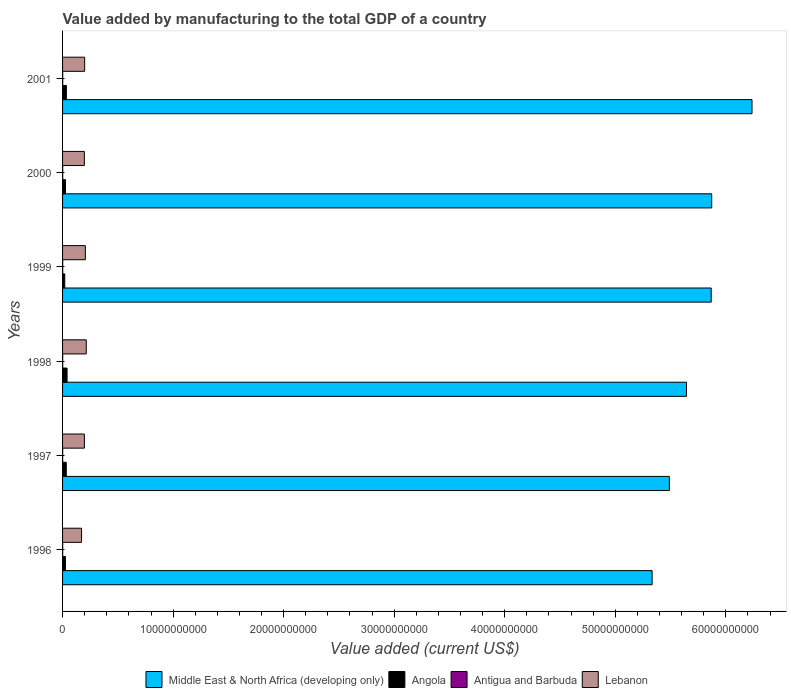How many different coloured bars are there?
Offer a terse response. 4. Are the number of bars per tick equal to the number of legend labels?
Ensure brevity in your answer.  Yes. Are the number of bars on each tick of the Y-axis equal?
Make the answer very short. Yes. How many bars are there on the 5th tick from the top?
Make the answer very short. 4. In how many cases, is the number of bars for a given year not equal to the number of legend labels?
Offer a terse response. 0. What is the value added by manufacturing to the total GDP in Angola in 1997?
Provide a short and direct response. 3.35e+08. Across all years, what is the maximum value added by manufacturing to the total GDP in Antigua and Barbuda?
Give a very brief answer. 1.39e+07. Across all years, what is the minimum value added by manufacturing to the total GDP in Middle East & North Africa (developing only)?
Give a very brief answer. 5.33e+1. In which year was the value added by manufacturing to the total GDP in Middle East & North Africa (developing only) maximum?
Your answer should be compact. 2001. In which year was the value added by manufacturing to the total GDP in Antigua and Barbuda minimum?
Provide a succinct answer. 1996. What is the total value added by manufacturing to the total GDP in Antigua and Barbuda in the graph?
Offer a very short reply. 7.24e+07. What is the difference between the value added by manufacturing to the total GDP in Lebanon in 1998 and that in 2001?
Your answer should be compact. 1.45e+08. What is the difference between the value added by manufacturing to the total GDP in Middle East & North Africa (developing only) in 1996 and the value added by manufacturing to the total GDP in Antigua and Barbuda in 1999?
Keep it short and to the point. 5.33e+1. What is the average value added by manufacturing to the total GDP in Lebanon per year?
Offer a very short reply. 1.98e+09. In the year 1999, what is the difference between the value added by manufacturing to the total GDP in Angola and value added by manufacturing to the total GDP in Middle East & North Africa (developing only)?
Your answer should be compact. -5.85e+1. What is the ratio of the value added by manufacturing to the total GDP in Antigua and Barbuda in 1996 to that in 2000?
Make the answer very short. 0.74. Is the value added by manufacturing to the total GDP in Antigua and Barbuda in 2000 less than that in 2001?
Your answer should be very brief. Yes. What is the difference between the highest and the second highest value added by manufacturing to the total GDP in Angola?
Your answer should be very brief. 6.12e+07. What is the difference between the highest and the lowest value added by manufacturing to the total GDP in Antigua and Barbuda?
Keep it short and to the point. 3.98e+06. In how many years, is the value added by manufacturing to the total GDP in Angola greater than the average value added by manufacturing to the total GDP in Angola taken over all years?
Your answer should be very brief. 3. Is the sum of the value added by manufacturing to the total GDP in Lebanon in 1999 and 2000 greater than the maximum value added by manufacturing to the total GDP in Middle East & North Africa (developing only) across all years?
Keep it short and to the point. No. Is it the case that in every year, the sum of the value added by manufacturing to the total GDP in Middle East & North Africa (developing only) and value added by manufacturing to the total GDP in Angola is greater than the sum of value added by manufacturing to the total GDP in Antigua and Barbuda and value added by manufacturing to the total GDP in Lebanon?
Ensure brevity in your answer.  No. What does the 4th bar from the top in 2001 represents?
Ensure brevity in your answer.  Middle East & North Africa (developing only). What does the 1st bar from the bottom in 1998 represents?
Give a very brief answer. Middle East & North Africa (developing only). Is it the case that in every year, the sum of the value added by manufacturing to the total GDP in Middle East & North Africa (developing only) and value added by manufacturing to the total GDP in Angola is greater than the value added by manufacturing to the total GDP in Antigua and Barbuda?
Keep it short and to the point. Yes. How many bars are there?
Your response must be concise. 24. Are all the bars in the graph horizontal?
Offer a very short reply. Yes. Does the graph contain grids?
Your response must be concise. No. What is the title of the graph?
Keep it short and to the point. Value added by manufacturing to the total GDP of a country. Does "Arab World" appear as one of the legend labels in the graph?
Offer a very short reply. No. What is the label or title of the X-axis?
Ensure brevity in your answer.  Value added (current US$). What is the Value added (current US$) of Middle East & North Africa (developing only) in 1996?
Provide a succinct answer. 5.33e+1. What is the Value added (current US$) of Angola in 1996?
Give a very brief answer. 2.59e+08. What is the Value added (current US$) in Antigua and Barbuda in 1996?
Your answer should be very brief. 9.95e+06. What is the Value added (current US$) of Lebanon in 1996?
Ensure brevity in your answer.  1.72e+09. What is the Value added (current US$) of Middle East & North Africa (developing only) in 1997?
Your response must be concise. 5.49e+1. What is the Value added (current US$) in Angola in 1997?
Offer a very short reply. 3.35e+08. What is the Value added (current US$) of Antigua and Barbuda in 1997?
Your answer should be very brief. 1.08e+07. What is the Value added (current US$) of Lebanon in 1997?
Your answer should be compact. 1.97e+09. What is the Value added (current US$) in Middle East & North Africa (developing only) in 1998?
Offer a very short reply. 5.64e+1. What is the Value added (current US$) of Angola in 1998?
Offer a very short reply. 4.07e+08. What is the Value added (current US$) in Antigua and Barbuda in 1998?
Provide a succinct answer. 1.17e+07. What is the Value added (current US$) of Lebanon in 1998?
Ensure brevity in your answer.  2.14e+09. What is the Value added (current US$) in Middle East & North Africa (developing only) in 1999?
Offer a terse response. 5.87e+1. What is the Value added (current US$) of Angola in 1999?
Offer a terse response. 1.98e+08. What is the Value added (current US$) in Antigua and Barbuda in 1999?
Your answer should be very brief. 1.25e+07. What is the Value added (current US$) in Lebanon in 1999?
Keep it short and to the point. 2.06e+09. What is the Value added (current US$) in Middle East & North Africa (developing only) in 2000?
Offer a terse response. 5.87e+1. What is the Value added (current US$) in Angola in 2000?
Your response must be concise. 2.64e+08. What is the Value added (current US$) in Antigua and Barbuda in 2000?
Your answer should be compact. 1.35e+07. What is the Value added (current US$) of Lebanon in 2000?
Provide a short and direct response. 1.97e+09. What is the Value added (current US$) in Middle East & North Africa (developing only) in 2001?
Offer a terse response. 6.24e+1. What is the Value added (current US$) of Angola in 2001?
Offer a very short reply. 3.46e+08. What is the Value added (current US$) in Antigua and Barbuda in 2001?
Your answer should be very brief. 1.39e+07. What is the Value added (current US$) in Lebanon in 2001?
Your response must be concise. 2.00e+09. Across all years, what is the maximum Value added (current US$) of Middle East & North Africa (developing only)?
Ensure brevity in your answer.  6.24e+1. Across all years, what is the maximum Value added (current US$) in Angola?
Offer a terse response. 4.07e+08. Across all years, what is the maximum Value added (current US$) in Antigua and Barbuda?
Provide a short and direct response. 1.39e+07. Across all years, what is the maximum Value added (current US$) in Lebanon?
Keep it short and to the point. 2.14e+09. Across all years, what is the minimum Value added (current US$) in Middle East & North Africa (developing only)?
Offer a terse response. 5.33e+1. Across all years, what is the minimum Value added (current US$) of Angola?
Keep it short and to the point. 1.98e+08. Across all years, what is the minimum Value added (current US$) of Antigua and Barbuda?
Offer a very short reply. 9.95e+06. Across all years, what is the minimum Value added (current US$) in Lebanon?
Make the answer very short. 1.72e+09. What is the total Value added (current US$) of Middle East & North Africa (developing only) in the graph?
Keep it short and to the point. 3.44e+11. What is the total Value added (current US$) in Angola in the graph?
Your answer should be very brief. 1.81e+09. What is the total Value added (current US$) of Antigua and Barbuda in the graph?
Provide a succinct answer. 7.24e+07. What is the total Value added (current US$) of Lebanon in the graph?
Provide a short and direct response. 1.19e+1. What is the difference between the Value added (current US$) of Middle East & North Africa (developing only) in 1996 and that in 1997?
Ensure brevity in your answer.  -1.56e+09. What is the difference between the Value added (current US$) of Angola in 1996 and that in 1997?
Provide a short and direct response. -7.56e+07. What is the difference between the Value added (current US$) of Antigua and Barbuda in 1996 and that in 1997?
Offer a terse response. -8.59e+05. What is the difference between the Value added (current US$) of Lebanon in 1996 and that in 1997?
Offer a very short reply. -2.56e+08. What is the difference between the Value added (current US$) in Middle East & North Africa (developing only) in 1996 and that in 1998?
Your answer should be very brief. -3.11e+09. What is the difference between the Value added (current US$) of Angola in 1996 and that in 1998?
Keep it short and to the point. -1.48e+08. What is the difference between the Value added (current US$) of Antigua and Barbuda in 1996 and that in 1998?
Provide a succinct answer. -1.79e+06. What is the difference between the Value added (current US$) in Lebanon in 1996 and that in 1998?
Offer a terse response. -4.26e+08. What is the difference between the Value added (current US$) of Middle East & North Africa (developing only) in 1996 and that in 1999?
Provide a succinct answer. -5.35e+09. What is the difference between the Value added (current US$) of Angola in 1996 and that in 1999?
Keep it short and to the point. 6.11e+07. What is the difference between the Value added (current US$) of Antigua and Barbuda in 1996 and that in 1999?
Your response must be concise. -2.57e+06. What is the difference between the Value added (current US$) in Lebanon in 1996 and that in 1999?
Keep it short and to the point. -3.45e+08. What is the difference between the Value added (current US$) in Middle East & North Africa (developing only) in 1996 and that in 2000?
Keep it short and to the point. -5.39e+09. What is the difference between the Value added (current US$) of Angola in 1996 and that in 2000?
Provide a succinct answer. -4.50e+06. What is the difference between the Value added (current US$) in Antigua and Barbuda in 1996 and that in 2000?
Your answer should be compact. -3.53e+06. What is the difference between the Value added (current US$) in Lebanon in 1996 and that in 2000?
Offer a terse response. -2.53e+08. What is the difference between the Value added (current US$) in Middle East & North Africa (developing only) in 1996 and that in 2001?
Provide a short and direct response. -9.04e+09. What is the difference between the Value added (current US$) of Angola in 1996 and that in 2001?
Keep it short and to the point. -8.67e+07. What is the difference between the Value added (current US$) in Antigua and Barbuda in 1996 and that in 2001?
Make the answer very short. -3.98e+06. What is the difference between the Value added (current US$) of Lebanon in 1996 and that in 2001?
Offer a very short reply. -2.82e+08. What is the difference between the Value added (current US$) of Middle East & North Africa (developing only) in 1997 and that in 1998?
Offer a very short reply. -1.55e+09. What is the difference between the Value added (current US$) in Angola in 1997 and that in 1998?
Offer a very short reply. -7.23e+07. What is the difference between the Value added (current US$) of Antigua and Barbuda in 1997 and that in 1998?
Make the answer very short. -9.33e+05. What is the difference between the Value added (current US$) of Lebanon in 1997 and that in 1998?
Keep it short and to the point. -1.71e+08. What is the difference between the Value added (current US$) in Middle East & North Africa (developing only) in 1997 and that in 1999?
Give a very brief answer. -3.79e+09. What is the difference between the Value added (current US$) of Angola in 1997 and that in 1999?
Your answer should be very brief. 1.37e+08. What is the difference between the Value added (current US$) in Antigua and Barbuda in 1997 and that in 1999?
Your answer should be compact. -1.71e+06. What is the difference between the Value added (current US$) in Lebanon in 1997 and that in 1999?
Provide a succinct answer. -8.92e+07. What is the difference between the Value added (current US$) in Middle East & North Africa (developing only) in 1997 and that in 2000?
Give a very brief answer. -3.83e+09. What is the difference between the Value added (current US$) in Angola in 1997 and that in 2000?
Keep it short and to the point. 7.11e+07. What is the difference between the Value added (current US$) of Antigua and Barbuda in 1997 and that in 2000?
Your answer should be very brief. -2.68e+06. What is the difference between the Value added (current US$) in Lebanon in 1997 and that in 2000?
Provide a succinct answer. 2.57e+06. What is the difference between the Value added (current US$) in Middle East & North Africa (developing only) in 1997 and that in 2001?
Provide a succinct answer. -7.48e+09. What is the difference between the Value added (current US$) in Angola in 1997 and that in 2001?
Offer a terse response. -1.12e+07. What is the difference between the Value added (current US$) in Antigua and Barbuda in 1997 and that in 2001?
Offer a terse response. -3.12e+06. What is the difference between the Value added (current US$) of Lebanon in 1997 and that in 2001?
Offer a terse response. -2.60e+07. What is the difference between the Value added (current US$) of Middle East & North Africa (developing only) in 1998 and that in 1999?
Provide a short and direct response. -2.23e+09. What is the difference between the Value added (current US$) of Angola in 1998 and that in 1999?
Your response must be concise. 2.09e+08. What is the difference between the Value added (current US$) of Antigua and Barbuda in 1998 and that in 1999?
Your answer should be very brief. -7.78e+05. What is the difference between the Value added (current US$) in Lebanon in 1998 and that in 1999?
Give a very brief answer. 8.17e+07. What is the difference between the Value added (current US$) of Middle East & North Africa (developing only) in 1998 and that in 2000?
Your answer should be very brief. -2.28e+09. What is the difference between the Value added (current US$) in Angola in 1998 and that in 2000?
Offer a terse response. 1.43e+08. What is the difference between the Value added (current US$) in Antigua and Barbuda in 1998 and that in 2000?
Your answer should be compact. -1.74e+06. What is the difference between the Value added (current US$) in Lebanon in 1998 and that in 2000?
Your response must be concise. 1.73e+08. What is the difference between the Value added (current US$) of Middle East & North Africa (developing only) in 1998 and that in 2001?
Your answer should be very brief. -5.93e+09. What is the difference between the Value added (current US$) of Angola in 1998 and that in 2001?
Offer a very short reply. 6.12e+07. What is the difference between the Value added (current US$) in Antigua and Barbuda in 1998 and that in 2001?
Your response must be concise. -2.19e+06. What is the difference between the Value added (current US$) of Lebanon in 1998 and that in 2001?
Offer a very short reply. 1.45e+08. What is the difference between the Value added (current US$) in Middle East & North Africa (developing only) in 1999 and that in 2000?
Your response must be concise. -4.71e+07. What is the difference between the Value added (current US$) of Angola in 1999 and that in 2000?
Give a very brief answer. -6.56e+07. What is the difference between the Value added (current US$) in Antigua and Barbuda in 1999 and that in 2000?
Provide a succinct answer. -9.64e+05. What is the difference between the Value added (current US$) of Lebanon in 1999 and that in 2000?
Offer a very short reply. 9.17e+07. What is the difference between the Value added (current US$) of Middle East & North Africa (developing only) in 1999 and that in 2001?
Keep it short and to the point. -3.69e+09. What is the difference between the Value added (current US$) in Angola in 1999 and that in 2001?
Keep it short and to the point. -1.48e+08. What is the difference between the Value added (current US$) in Antigua and Barbuda in 1999 and that in 2001?
Offer a very short reply. -1.41e+06. What is the difference between the Value added (current US$) of Lebanon in 1999 and that in 2001?
Keep it short and to the point. 6.32e+07. What is the difference between the Value added (current US$) in Middle East & North Africa (developing only) in 2000 and that in 2001?
Your response must be concise. -3.65e+09. What is the difference between the Value added (current US$) of Angola in 2000 and that in 2001?
Ensure brevity in your answer.  -8.22e+07. What is the difference between the Value added (current US$) of Antigua and Barbuda in 2000 and that in 2001?
Ensure brevity in your answer.  -4.47e+05. What is the difference between the Value added (current US$) in Lebanon in 2000 and that in 2001?
Provide a short and direct response. -2.85e+07. What is the difference between the Value added (current US$) of Middle East & North Africa (developing only) in 1996 and the Value added (current US$) of Angola in 1997?
Provide a succinct answer. 5.30e+1. What is the difference between the Value added (current US$) of Middle East & North Africa (developing only) in 1996 and the Value added (current US$) of Antigua and Barbuda in 1997?
Give a very brief answer. 5.33e+1. What is the difference between the Value added (current US$) in Middle East & North Africa (developing only) in 1996 and the Value added (current US$) in Lebanon in 1997?
Provide a short and direct response. 5.14e+1. What is the difference between the Value added (current US$) of Angola in 1996 and the Value added (current US$) of Antigua and Barbuda in 1997?
Provide a succinct answer. 2.49e+08. What is the difference between the Value added (current US$) of Angola in 1996 and the Value added (current US$) of Lebanon in 1997?
Offer a terse response. -1.71e+09. What is the difference between the Value added (current US$) in Antigua and Barbuda in 1996 and the Value added (current US$) in Lebanon in 1997?
Your response must be concise. -1.96e+09. What is the difference between the Value added (current US$) in Middle East & North Africa (developing only) in 1996 and the Value added (current US$) in Angola in 1998?
Give a very brief answer. 5.29e+1. What is the difference between the Value added (current US$) in Middle East & North Africa (developing only) in 1996 and the Value added (current US$) in Antigua and Barbuda in 1998?
Your answer should be very brief. 5.33e+1. What is the difference between the Value added (current US$) of Middle East & North Africa (developing only) in 1996 and the Value added (current US$) of Lebanon in 1998?
Provide a succinct answer. 5.12e+1. What is the difference between the Value added (current US$) of Angola in 1996 and the Value added (current US$) of Antigua and Barbuda in 1998?
Offer a very short reply. 2.48e+08. What is the difference between the Value added (current US$) in Angola in 1996 and the Value added (current US$) in Lebanon in 1998?
Make the answer very short. -1.88e+09. What is the difference between the Value added (current US$) of Antigua and Barbuda in 1996 and the Value added (current US$) of Lebanon in 1998?
Ensure brevity in your answer.  -2.13e+09. What is the difference between the Value added (current US$) of Middle East & North Africa (developing only) in 1996 and the Value added (current US$) of Angola in 1999?
Your answer should be compact. 5.31e+1. What is the difference between the Value added (current US$) in Middle East & North Africa (developing only) in 1996 and the Value added (current US$) in Antigua and Barbuda in 1999?
Your response must be concise. 5.33e+1. What is the difference between the Value added (current US$) of Middle East & North Africa (developing only) in 1996 and the Value added (current US$) of Lebanon in 1999?
Provide a succinct answer. 5.13e+1. What is the difference between the Value added (current US$) of Angola in 1996 and the Value added (current US$) of Antigua and Barbuda in 1999?
Ensure brevity in your answer.  2.47e+08. What is the difference between the Value added (current US$) in Angola in 1996 and the Value added (current US$) in Lebanon in 1999?
Your answer should be very brief. -1.80e+09. What is the difference between the Value added (current US$) in Antigua and Barbuda in 1996 and the Value added (current US$) in Lebanon in 1999?
Offer a terse response. -2.05e+09. What is the difference between the Value added (current US$) of Middle East & North Africa (developing only) in 1996 and the Value added (current US$) of Angola in 2000?
Your answer should be compact. 5.31e+1. What is the difference between the Value added (current US$) in Middle East & North Africa (developing only) in 1996 and the Value added (current US$) in Antigua and Barbuda in 2000?
Provide a succinct answer. 5.33e+1. What is the difference between the Value added (current US$) in Middle East & North Africa (developing only) in 1996 and the Value added (current US$) in Lebanon in 2000?
Your answer should be compact. 5.14e+1. What is the difference between the Value added (current US$) in Angola in 1996 and the Value added (current US$) in Antigua and Barbuda in 2000?
Provide a short and direct response. 2.46e+08. What is the difference between the Value added (current US$) of Angola in 1996 and the Value added (current US$) of Lebanon in 2000?
Your response must be concise. -1.71e+09. What is the difference between the Value added (current US$) of Antigua and Barbuda in 1996 and the Value added (current US$) of Lebanon in 2000?
Your answer should be compact. -1.96e+09. What is the difference between the Value added (current US$) in Middle East & North Africa (developing only) in 1996 and the Value added (current US$) in Angola in 2001?
Make the answer very short. 5.30e+1. What is the difference between the Value added (current US$) in Middle East & North Africa (developing only) in 1996 and the Value added (current US$) in Antigua and Barbuda in 2001?
Give a very brief answer. 5.33e+1. What is the difference between the Value added (current US$) in Middle East & North Africa (developing only) in 1996 and the Value added (current US$) in Lebanon in 2001?
Make the answer very short. 5.13e+1. What is the difference between the Value added (current US$) in Angola in 1996 and the Value added (current US$) in Antigua and Barbuda in 2001?
Your response must be concise. 2.45e+08. What is the difference between the Value added (current US$) in Angola in 1996 and the Value added (current US$) in Lebanon in 2001?
Your answer should be compact. -1.74e+09. What is the difference between the Value added (current US$) of Antigua and Barbuda in 1996 and the Value added (current US$) of Lebanon in 2001?
Provide a succinct answer. -1.99e+09. What is the difference between the Value added (current US$) in Middle East & North Africa (developing only) in 1997 and the Value added (current US$) in Angola in 1998?
Ensure brevity in your answer.  5.45e+1. What is the difference between the Value added (current US$) of Middle East & North Africa (developing only) in 1997 and the Value added (current US$) of Antigua and Barbuda in 1998?
Your answer should be compact. 5.49e+1. What is the difference between the Value added (current US$) of Middle East & North Africa (developing only) in 1997 and the Value added (current US$) of Lebanon in 1998?
Offer a terse response. 5.27e+1. What is the difference between the Value added (current US$) of Angola in 1997 and the Value added (current US$) of Antigua and Barbuda in 1998?
Your answer should be compact. 3.23e+08. What is the difference between the Value added (current US$) in Angola in 1997 and the Value added (current US$) in Lebanon in 1998?
Provide a succinct answer. -1.81e+09. What is the difference between the Value added (current US$) in Antigua and Barbuda in 1997 and the Value added (current US$) in Lebanon in 1998?
Provide a short and direct response. -2.13e+09. What is the difference between the Value added (current US$) in Middle East & North Africa (developing only) in 1997 and the Value added (current US$) in Angola in 1999?
Provide a short and direct response. 5.47e+1. What is the difference between the Value added (current US$) in Middle East & North Africa (developing only) in 1997 and the Value added (current US$) in Antigua and Barbuda in 1999?
Keep it short and to the point. 5.49e+1. What is the difference between the Value added (current US$) of Middle East & North Africa (developing only) in 1997 and the Value added (current US$) of Lebanon in 1999?
Keep it short and to the point. 5.28e+1. What is the difference between the Value added (current US$) in Angola in 1997 and the Value added (current US$) in Antigua and Barbuda in 1999?
Your answer should be very brief. 3.22e+08. What is the difference between the Value added (current US$) of Angola in 1997 and the Value added (current US$) of Lebanon in 1999?
Provide a succinct answer. -1.73e+09. What is the difference between the Value added (current US$) in Antigua and Barbuda in 1997 and the Value added (current US$) in Lebanon in 1999?
Offer a very short reply. -2.05e+09. What is the difference between the Value added (current US$) of Middle East & North Africa (developing only) in 1997 and the Value added (current US$) of Angola in 2000?
Provide a short and direct response. 5.46e+1. What is the difference between the Value added (current US$) in Middle East & North Africa (developing only) in 1997 and the Value added (current US$) in Antigua and Barbuda in 2000?
Give a very brief answer. 5.49e+1. What is the difference between the Value added (current US$) of Middle East & North Africa (developing only) in 1997 and the Value added (current US$) of Lebanon in 2000?
Offer a terse response. 5.29e+1. What is the difference between the Value added (current US$) in Angola in 1997 and the Value added (current US$) in Antigua and Barbuda in 2000?
Offer a very short reply. 3.21e+08. What is the difference between the Value added (current US$) in Angola in 1997 and the Value added (current US$) in Lebanon in 2000?
Your answer should be compact. -1.64e+09. What is the difference between the Value added (current US$) in Antigua and Barbuda in 1997 and the Value added (current US$) in Lebanon in 2000?
Provide a succinct answer. -1.96e+09. What is the difference between the Value added (current US$) of Middle East & North Africa (developing only) in 1997 and the Value added (current US$) of Angola in 2001?
Your answer should be compact. 5.45e+1. What is the difference between the Value added (current US$) of Middle East & North Africa (developing only) in 1997 and the Value added (current US$) of Antigua and Barbuda in 2001?
Offer a very short reply. 5.49e+1. What is the difference between the Value added (current US$) of Middle East & North Africa (developing only) in 1997 and the Value added (current US$) of Lebanon in 2001?
Offer a very short reply. 5.29e+1. What is the difference between the Value added (current US$) of Angola in 1997 and the Value added (current US$) of Antigua and Barbuda in 2001?
Provide a short and direct response. 3.21e+08. What is the difference between the Value added (current US$) in Angola in 1997 and the Value added (current US$) in Lebanon in 2001?
Offer a very short reply. -1.66e+09. What is the difference between the Value added (current US$) in Antigua and Barbuda in 1997 and the Value added (current US$) in Lebanon in 2001?
Your response must be concise. -1.99e+09. What is the difference between the Value added (current US$) of Middle East & North Africa (developing only) in 1998 and the Value added (current US$) of Angola in 1999?
Provide a succinct answer. 5.62e+1. What is the difference between the Value added (current US$) of Middle East & North Africa (developing only) in 1998 and the Value added (current US$) of Antigua and Barbuda in 1999?
Ensure brevity in your answer.  5.64e+1. What is the difference between the Value added (current US$) in Middle East & North Africa (developing only) in 1998 and the Value added (current US$) in Lebanon in 1999?
Your answer should be compact. 5.44e+1. What is the difference between the Value added (current US$) in Angola in 1998 and the Value added (current US$) in Antigua and Barbuda in 1999?
Your answer should be very brief. 3.95e+08. What is the difference between the Value added (current US$) of Angola in 1998 and the Value added (current US$) of Lebanon in 1999?
Ensure brevity in your answer.  -1.65e+09. What is the difference between the Value added (current US$) of Antigua and Barbuda in 1998 and the Value added (current US$) of Lebanon in 1999?
Offer a terse response. -2.05e+09. What is the difference between the Value added (current US$) in Middle East & North Africa (developing only) in 1998 and the Value added (current US$) in Angola in 2000?
Offer a terse response. 5.62e+1. What is the difference between the Value added (current US$) of Middle East & North Africa (developing only) in 1998 and the Value added (current US$) of Antigua and Barbuda in 2000?
Your answer should be compact. 5.64e+1. What is the difference between the Value added (current US$) of Middle East & North Africa (developing only) in 1998 and the Value added (current US$) of Lebanon in 2000?
Provide a short and direct response. 5.45e+1. What is the difference between the Value added (current US$) in Angola in 1998 and the Value added (current US$) in Antigua and Barbuda in 2000?
Your answer should be very brief. 3.94e+08. What is the difference between the Value added (current US$) in Angola in 1998 and the Value added (current US$) in Lebanon in 2000?
Your answer should be compact. -1.56e+09. What is the difference between the Value added (current US$) of Antigua and Barbuda in 1998 and the Value added (current US$) of Lebanon in 2000?
Make the answer very short. -1.96e+09. What is the difference between the Value added (current US$) of Middle East & North Africa (developing only) in 1998 and the Value added (current US$) of Angola in 2001?
Your response must be concise. 5.61e+1. What is the difference between the Value added (current US$) of Middle East & North Africa (developing only) in 1998 and the Value added (current US$) of Antigua and Barbuda in 2001?
Provide a succinct answer. 5.64e+1. What is the difference between the Value added (current US$) of Middle East & North Africa (developing only) in 1998 and the Value added (current US$) of Lebanon in 2001?
Keep it short and to the point. 5.44e+1. What is the difference between the Value added (current US$) in Angola in 1998 and the Value added (current US$) in Antigua and Barbuda in 2001?
Offer a terse response. 3.93e+08. What is the difference between the Value added (current US$) of Angola in 1998 and the Value added (current US$) of Lebanon in 2001?
Provide a succinct answer. -1.59e+09. What is the difference between the Value added (current US$) of Antigua and Barbuda in 1998 and the Value added (current US$) of Lebanon in 2001?
Your answer should be compact. -1.99e+09. What is the difference between the Value added (current US$) of Middle East & North Africa (developing only) in 1999 and the Value added (current US$) of Angola in 2000?
Provide a short and direct response. 5.84e+1. What is the difference between the Value added (current US$) in Middle East & North Africa (developing only) in 1999 and the Value added (current US$) in Antigua and Barbuda in 2000?
Provide a succinct answer. 5.87e+1. What is the difference between the Value added (current US$) of Middle East & North Africa (developing only) in 1999 and the Value added (current US$) of Lebanon in 2000?
Your answer should be very brief. 5.67e+1. What is the difference between the Value added (current US$) in Angola in 1999 and the Value added (current US$) in Antigua and Barbuda in 2000?
Offer a very short reply. 1.85e+08. What is the difference between the Value added (current US$) in Angola in 1999 and the Value added (current US$) in Lebanon in 2000?
Your response must be concise. -1.77e+09. What is the difference between the Value added (current US$) in Antigua and Barbuda in 1999 and the Value added (current US$) in Lebanon in 2000?
Ensure brevity in your answer.  -1.96e+09. What is the difference between the Value added (current US$) of Middle East & North Africa (developing only) in 1999 and the Value added (current US$) of Angola in 2001?
Give a very brief answer. 5.83e+1. What is the difference between the Value added (current US$) in Middle East & North Africa (developing only) in 1999 and the Value added (current US$) in Antigua and Barbuda in 2001?
Offer a terse response. 5.87e+1. What is the difference between the Value added (current US$) in Middle East & North Africa (developing only) in 1999 and the Value added (current US$) in Lebanon in 2001?
Provide a short and direct response. 5.67e+1. What is the difference between the Value added (current US$) in Angola in 1999 and the Value added (current US$) in Antigua and Barbuda in 2001?
Offer a terse response. 1.84e+08. What is the difference between the Value added (current US$) in Angola in 1999 and the Value added (current US$) in Lebanon in 2001?
Provide a succinct answer. -1.80e+09. What is the difference between the Value added (current US$) in Antigua and Barbuda in 1999 and the Value added (current US$) in Lebanon in 2001?
Keep it short and to the point. -1.99e+09. What is the difference between the Value added (current US$) in Middle East & North Africa (developing only) in 2000 and the Value added (current US$) in Angola in 2001?
Offer a very short reply. 5.84e+1. What is the difference between the Value added (current US$) in Middle East & North Africa (developing only) in 2000 and the Value added (current US$) in Antigua and Barbuda in 2001?
Your response must be concise. 5.87e+1. What is the difference between the Value added (current US$) in Middle East & North Africa (developing only) in 2000 and the Value added (current US$) in Lebanon in 2001?
Give a very brief answer. 5.67e+1. What is the difference between the Value added (current US$) of Angola in 2000 and the Value added (current US$) of Antigua and Barbuda in 2001?
Offer a terse response. 2.50e+08. What is the difference between the Value added (current US$) of Angola in 2000 and the Value added (current US$) of Lebanon in 2001?
Offer a terse response. -1.73e+09. What is the difference between the Value added (current US$) in Antigua and Barbuda in 2000 and the Value added (current US$) in Lebanon in 2001?
Provide a succinct answer. -1.99e+09. What is the average Value added (current US$) of Middle East & North Africa (developing only) per year?
Your response must be concise. 5.74e+1. What is the average Value added (current US$) of Angola per year?
Your answer should be compact. 3.02e+08. What is the average Value added (current US$) in Antigua and Barbuda per year?
Provide a succinct answer. 1.21e+07. What is the average Value added (current US$) of Lebanon per year?
Provide a succinct answer. 1.98e+09. In the year 1996, what is the difference between the Value added (current US$) of Middle East & North Africa (developing only) and Value added (current US$) of Angola?
Make the answer very short. 5.31e+1. In the year 1996, what is the difference between the Value added (current US$) in Middle East & North Africa (developing only) and Value added (current US$) in Antigua and Barbuda?
Offer a very short reply. 5.33e+1. In the year 1996, what is the difference between the Value added (current US$) in Middle East & North Africa (developing only) and Value added (current US$) in Lebanon?
Ensure brevity in your answer.  5.16e+1. In the year 1996, what is the difference between the Value added (current US$) in Angola and Value added (current US$) in Antigua and Barbuda?
Your answer should be very brief. 2.49e+08. In the year 1996, what is the difference between the Value added (current US$) in Angola and Value added (current US$) in Lebanon?
Offer a terse response. -1.46e+09. In the year 1996, what is the difference between the Value added (current US$) of Antigua and Barbuda and Value added (current US$) of Lebanon?
Your answer should be very brief. -1.71e+09. In the year 1997, what is the difference between the Value added (current US$) of Middle East & North Africa (developing only) and Value added (current US$) of Angola?
Your answer should be compact. 5.46e+1. In the year 1997, what is the difference between the Value added (current US$) of Middle East & North Africa (developing only) and Value added (current US$) of Antigua and Barbuda?
Keep it short and to the point. 5.49e+1. In the year 1997, what is the difference between the Value added (current US$) in Middle East & North Africa (developing only) and Value added (current US$) in Lebanon?
Your answer should be very brief. 5.29e+1. In the year 1997, what is the difference between the Value added (current US$) of Angola and Value added (current US$) of Antigua and Barbuda?
Make the answer very short. 3.24e+08. In the year 1997, what is the difference between the Value added (current US$) in Angola and Value added (current US$) in Lebanon?
Offer a terse response. -1.64e+09. In the year 1997, what is the difference between the Value added (current US$) in Antigua and Barbuda and Value added (current US$) in Lebanon?
Ensure brevity in your answer.  -1.96e+09. In the year 1998, what is the difference between the Value added (current US$) of Middle East & North Africa (developing only) and Value added (current US$) of Angola?
Make the answer very short. 5.60e+1. In the year 1998, what is the difference between the Value added (current US$) of Middle East & North Africa (developing only) and Value added (current US$) of Antigua and Barbuda?
Make the answer very short. 5.64e+1. In the year 1998, what is the difference between the Value added (current US$) in Middle East & North Africa (developing only) and Value added (current US$) in Lebanon?
Provide a short and direct response. 5.43e+1. In the year 1998, what is the difference between the Value added (current US$) in Angola and Value added (current US$) in Antigua and Barbuda?
Your answer should be compact. 3.96e+08. In the year 1998, what is the difference between the Value added (current US$) in Angola and Value added (current US$) in Lebanon?
Your response must be concise. -1.74e+09. In the year 1998, what is the difference between the Value added (current US$) of Antigua and Barbuda and Value added (current US$) of Lebanon?
Make the answer very short. -2.13e+09. In the year 1999, what is the difference between the Value added (current US$) in Middle East & North Africa (developing only) and Value added (current US$) in Angola?
Offer a very short reply. 5.85e+1. In the year 1999, what is the difference between the Value added (current US$) of Middle East & North Africa (developing only) and Value added (current US$) of Antigua and Barbuda?
Your response must be concise. 5.87e+1. In the year 1999, what is the difference between the Value added (current US$) of Middle East & North Africa (developing only) and Value added (current US$) of Lebanon?
Offer a terse response. 5.66e+1. In the year 1999, what is the difference between the Value added (current US$) in Angola and Value added (current US$) in Antigua and Barbuda?
Provide a succinct answer. 1.86e+08. In the year 1999, what is the difference between the Value added (current US$) of Angola and Value added (current US$) of Lebanon?
Provide a succinct answer. -1.86e+09. In the year 1999, what is the difference between the Value added (current US$) of Antigua and Barbuda and Value added (current US$) of Lebanon?
Keep it short and to the point. -2.05e+09. In the year 2000, what is the difference between the Value added (current US$) in Middle East & North Africa (developing only) and Value added (current US$) in Angola?
Your answer should be very brief. 5.85e+1. In the year 2000, what is the difference between the Value added (current US$) of Middle East & North Africa (developing only) and Value added (current US$) of Antigua and Barbuda?
Give a very brief answer. 5.87e+1. In the year 2000, what is the difference between the Value added (current US$) of Middle East & North Africa (developing only) and Value added (current US$) of Lebanon?
Your answer should be compact. 5.68e+1. In the year 2000, what is the difference between the Value added (current US$) in Angola and Value added (current US$) in Antigua and Barbuda?
Make the answer very short. 2.50e+08. In the year 2000, what is the difference between the Value added (current US$) in Angola and Value added (current US$) in Lebanon?
Provide a short and direct response. -1.71e+09. In the year 2000, what is the difference between the Value added (current US$) of Antigua and Barbuda and Value added (current US$) of Lebanon?
Offer a very short reply. -1.96e+09. In the year 2001, what is the difference between the Value added (current US$) of Middle East & North Africa (developing only) and Value added (current US$) of Angola?
Provide a short and direct response. 6.20e+1. In the year 2001, what is the difference between the Value added (current US$) in Middle East & North Africa (developing only) and Value added (current US$) in Antigua and Barbuda?
Offer a very short reply. 6.24e+1. In the year 2001, what is the difference between the Value added (current US$) in Middle East & North Africa (developing only) and Value added (current US$) in Lebanon?
Provide a succinct answer. 6.04e+1. In the year 2001, what is the difference between the Value added (current US$) in Angola and Value added (current US$) in Antigua and Barbuda?
Your answer should be compact. 3.32e+08. In the year 2001, what is the difference between the Value added (current US$) of Angola and Value added (current US$) of Lebanon?
Offer a very short reply. -1.65e+09. In the year 2001, what is the difference between the Value added (current US$) in Antigua and Barbuda and Value added (current US$) in Lebanon?
Provide a short and direct response. -1.98e+09. What is the ratio of the Value added (current US$) in Middle East & North Africa (developing only) in 1996 to that in 1997?
Ensure brevity in your answer.  0.97. What is the ratio of the Value added (current US$) of Angola in 1996 to that in 1997?
Make the answer very short. 0.77. What is the ratio of the Value added (current US$) of Antigua and Barbuda in 1996 to that in 1997?
Give a very brief answer. 0.92. What is the ratio of the Value added (current US$) of Lebanon in 1996 to that in 1997?
Ensure brevity in your answer.  0.87. What is the ratio of the Value added (current US$) in Middle East & North Africa (developing only) in 1996 to that in 1998?
Provide a succinct answer. 0.94. What is the ratio of the Value added (current US$) in Angola in 1996 to that in 1998?
Offer a very short reply. 0.64. What is the ratio of the Value added (current US$) in Antigua and Barbuda in 1996 to that in 1998?
Keep it short and to the point. 0.85. What is the ratio of the Value added (current US$) in Lebanon in 1996 to that in 1998?
Provide a succinct answer. 0.8. What is the ratio of the Value added (current US$) of Middle East & North Africa (developing only) in 1996 to that in 1999?
Provide a short and direct response. 0.91. What is the ratio of the Value added (current US$) of Angola in 1996 to that in 1999?
Provide a succinct answer. 1.31. What is the ratio of the Value added (current US$) of Antigua and Barbuda in 1996 to that in 1999?
Offer a very short reply. 0.79. What is the ratio of the Value added (current US$) in Lebanon in 1996 to that in 1999?
Offer a terse response. 0.83. What is the ratio of the Value added (current US$) of Middle East & North Africa (developing only) in 1996 to that in 2000?
Provide a succinct answer. 0.91. What is the ratio of the Value added (current US$) in Angola in 1996 to that in 2000?
Keep it short and to the point. 0.98. What is the ratio of the Value added (current US$) of Antigua and Barbuda in 1996 to that in 2000?
Keep it short and to the point. 0.74. What is the ratio of the Value added (current US$) of Lebanon in 1996 to that in 2000?
Provide a succinct answer. 0.87. What is the ratio of the Value added (current US$) of Middle East & North Africa (developing only) in 1996 to that in 2001?
Give a very brief answer. 0.86. What is the ratio of the Value added (current US$) in Angola in 1996 to that in 2001?
Offer a very short reply. 0.75. What is the ratio of the Value added (current US$) in Antigua and Barbuda in 1996 to that in 2001?
Provide a short and direct response. 0.71. What is the ratio of the Value added (current US$) in Lebanon in 1996 to that in 2001?
Your answer should be compact. 0.86. What is the ratio of the Value added (current US$) in Middle East & North Africa (developing only) in 1997 to that in 1998?
Offer a terse response. 0.97. What is the ratio of the Value added (current US$) of Angola in 1997 to that in 1998?
Ensure brevity in your answer.  0.82. What is the ratio of the Value added (current US$) of Antigua and Barbuda in 1997 to that in 1998?
Provide a short and direct response. 0.92. What is the ratio of the Value added (current US$) in Lebanon in 1997 to that in 1998?
Ensure brevity in your answer.  0.92. What is the ratio of the Value added (current US$) of Middle East & North Africa (developing only) in 1997 to that in 1999?
Ensure brevity in your answer.  0.94. What is the ratio of the Value added (current US$) of Angola in 1997 to that in 1999?
Your answer should be compact. 1.69. What is the ratio of the Value added (current US$) of Antigua and Barbuda in 1997 to that in 1999?
Provide a succinct answer. 0.86. What is the ratio of the Value added (current US$) of Lebanon in 1997 to that in 1999?
Give a very brief answer. 0.96. What is the ratio of the Value added (current US$) of Middle East & North Africa (developing only) in 1997 to that in 2000?
Your response must be concise. 0.93. What is the ratio of the Value added (current US$) in Angola in 1997 to that in 2000?
Provide a succinct answer. 1.27. What is the ratio of the Value added (current US$) in Antigua and Barbuda in 1997 to that in 2000?
Make the answer very short. 0.8. What is the ratio of the Value added (current US$) in Middle East & North Africa (developing only) in 1997 to that in 2001?
Offer a very short reply. 0.88. What is the ratio of the Value added (current US$) in Angola in 1997 to that in 2001?
Make the answer very short. 0.97. What is the ratio of the Value added (current US$) in Antigua and Barbuda in 1997 to that in 2001?
Provide a short and direct response. 0.78. What is the ratio of the Value added (current US$) in Middle East & North Africa (developing only) in 1998 to that in 1999?
Keep it short and to the point. 0.96. What is the ratio of the Value added (current US$) in Angola in 1998 to that in 1999?
Provide a succinct answer. 2.05. What is the ratio of the Value added (current US$) of Antigua and Barbuda in 1998 to that in 1999?
Your response must be concise. 0.94. What is the ratio of the Value added (current US$) in Lebanon in 1998 to that in 1999?
Provide a short and direct response. 1.04. What is the ratio of the Value added (current US$) in Middle East & North Africa (developing only) in 1998 to that in 2000?
Make the answer very short. 0.96. What is the ratio of the Value added (current US$) in Angola in 1998 to that in 2000?
Provide a short and direct response. 1.54. What is the ratio of the Value added (current US$) in Antigua and Barbuda in 1998 to that in 2000?
Your answer should be compact. 0.87. What is the ratio of the Value added (current US$) of Lebanon in 1998 to that in 2000?
Ensure brevity in your answer.  1.09. What is the ratio of the Value added (current US$) in Middle East & North Africa (developing only) in 1998 to that in 2001?
Provide a succinct answer. 0.91. What is the ratio of the Value added (current US$) of Angola in 1998 to that in 2001?
Your answer should be compact. 1.18. What is the ratio of the Value added (current US$) in Antigua and Barbuda in 1998 to that in 2001?
Make the answer very short. 0.84. What is the ratio of the Value added (current US$) of Lebanon in 1998 to that in 2001?
Your answer should be very brief. 1.07. What is the ratio of the Value added (current US$) of Angola in 1999 to that in 2000?
Your response must be concise. 0.75. What is the ratio of the Value added (current US$) of Antigua and Barbuda in 1999 to that in 2000?
Make the answer very short. 0.93. What is the ratio of the Value added (current US$) in Lebanon in 1999 to that in 2000?
Give a very brief answer. 1.05. What is the ratio of the Value added (current US$) of Middle East & North Africa (developing only) in 1999 to that in 2001?
Keep it short and to the point. 0.94. What is the ratio of the Value added (current US$) of Angola in 1999 to that in 2001?
Provide a short and direct response. 0.57. What is the ratio of the Value added (current US$) of Antigua and Barbuda in 1999 to that in 2001?
Offer a terse response. 0.9. What is the ratio of the Value added (current US$) of Lebanon in 1999 to that in 2001?
Offer a terse response. 1.03. What is the ratio of the Value added (current US$) of Middle East & North Africa (developing only) in 2000 to that in 2001?
Your answer should be compact. 0.94. What is the ratio of the Value added (current US$) of Angola in 2000 to that in 2001?
Provide a succinct answer. 0.76. What is the ratio of the Value added (current US$) in Antigua and Barbuda in 2000 to that in 2001?
Ensure brevity in your answer.  0.97. What is the ratio of the Value added (current US$) in Lebanon in 2000 to that in 2001?
Provide a short and direct response. 0.99. What is the difference between the highest and the second highest Value added (current US$) of Middle East & North Africa (developing only)?
Ensure brevity in your answer.  3.65e+09. What is the difference between the highest and the second highest Value added (current US$) of Angola?
Your answer should be very brief. 6.12e+07. What is the difference between the highest and the second highest Value added (current US$) of Antigua and Barbuda?
Provide a short and direct response. 4.47e+05. What is the difference between the highest and the second highest Value added (current US$) of Lebanon?
Your response must be concise. 8.17e+07. What is the difference between the highest and the lowest Value added (current US$) in Middle East & North Africa (developing only)?
Provide a short and direct response. 9.04e+09. What is the difference between the highest and the lowest Value added (current US$) in Angola?
Ensure brevity in your answer.  2.09e+08. What is the difference between the highest and the lowest Value added (current US$) in Antigua and Barbuda?
Ensure brevity in your answer.  3.98e+06. What is the difference between the highest and the lowest Value added (current US$) of Lebanon?
Your answer should be compact. 4.26e+08. 